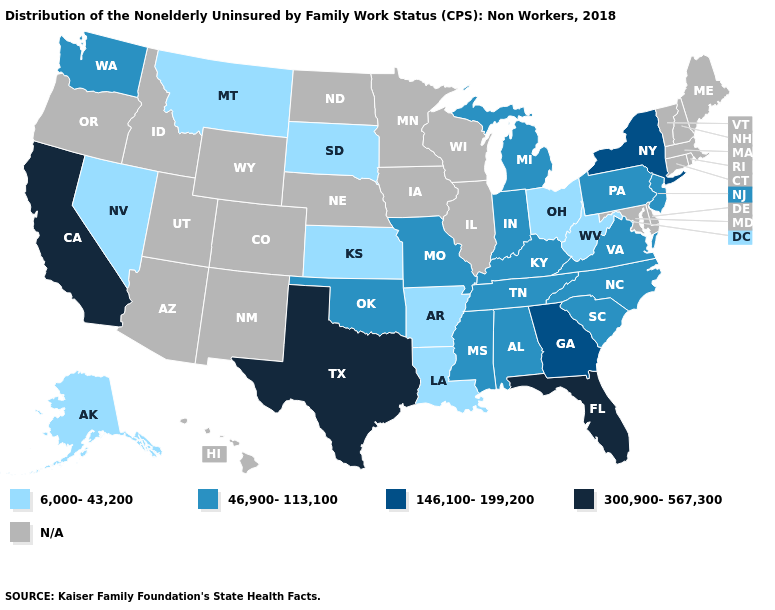Name the states that have a value in the range 6,000-43,200?
Answer briefly. Alaska, Arkansas, Kansas, Louisiana, Montana, Nevada, Ohio, South Dakota, West Virginia. What is the lowest value in the Northeast?
Answer briefly. 46,900-113,100. Does the map have missing data?
Keep it brief. Yes. Does Louisiana have the lowest value in the South?
Keep it brief. Yes. Which states have the lowest value in the USA?
Short answer required. Alaska, Arkansas, Kansas, Louisiana, Montana, Nevada, Ohio, South Dakota, West Virginia. What is the value of Delaware?
Concise answer only. N/A. What is the highest value in the USA?
Keep it brief. 300,900-567,300. What is the value of New Jersey?
Keep it brief. 46,900-113,100. Name the states that have a value in the range 46,900-113,100?
Be succinct. Alabama, Indiana, Kentucky, Michigan, Mississippi, Missouri, New Jersey, North Carolina, Oklahoma, Pennsylvania, South Carolina, Tennessee, Virginia, Washington. Which states have the highest value in the USA?
Quick response, please. California, Florida, Texas. Does the map have missing data?
Give a very brief answer. Yes. What is the value of Georgia?
Concise answer only. 146,100-199,200. Name the states that have a value in the range 6,000-43,200?
Keep it brief. Alaska, Arkansas, Kansas, Louisiana, Montana, Nevada, Ohio, South Dakota, West Virginia. What is the value of Utah?
Give a very brief answer. N/A. 